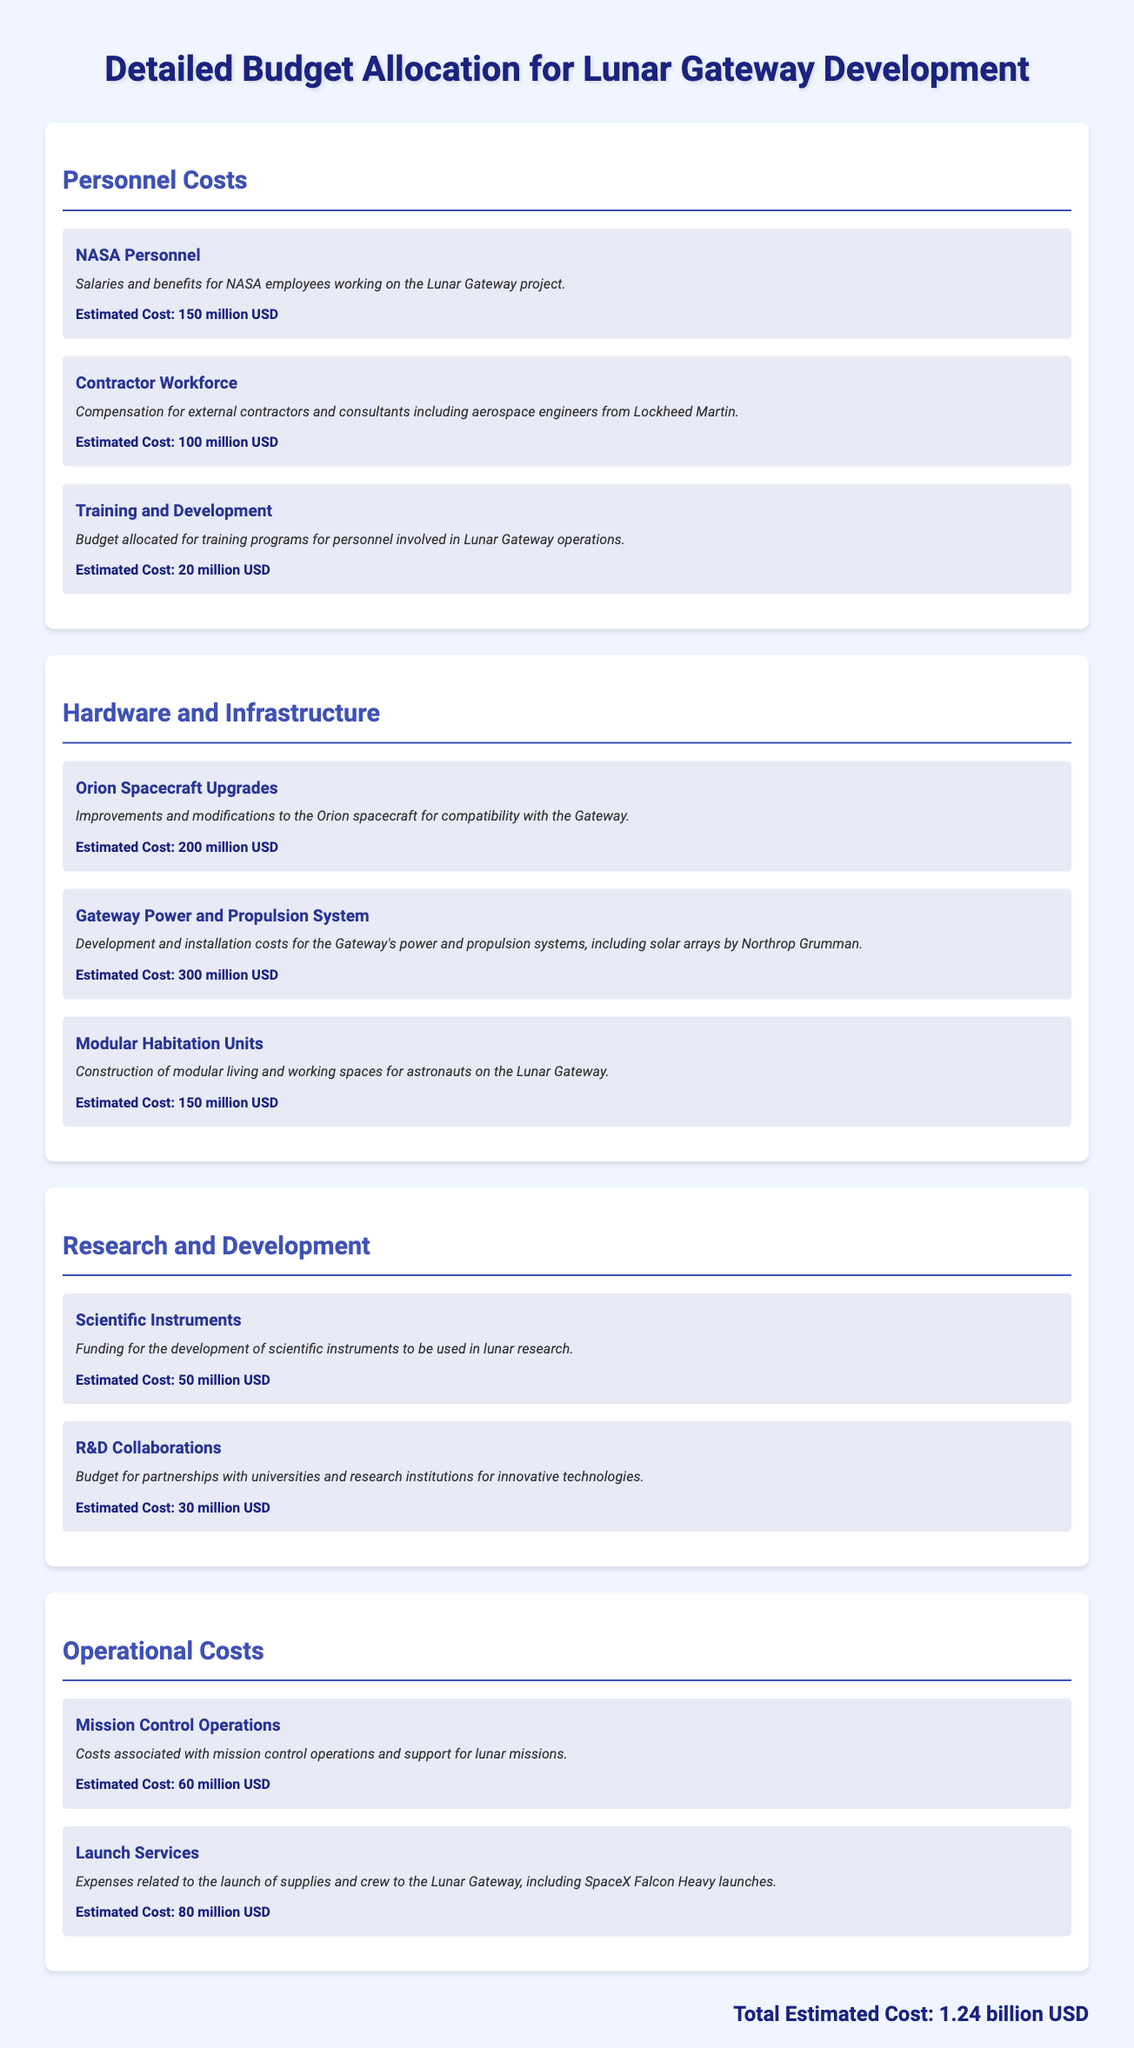What is the estimated cost for NASA Personnel? The estimated cost for NASA Personnel is explicitly mentioned in the document as 150 million USD.
Answer: 150 million USD What is the total estimated cost for the Lunar Gateway Development? The total estimated cost is summarized at the end of the document, which accounts for all budget allocations provided.
Answer: 1.24 billion USD What does the budget for Training and Development mainly cover? The document specifies that the budget for Training and Development is allocated for training programs for personnel involved in Lunar Gateway operations.
Answer: Training programs for personnel How much is allocated for the Gateway Power and Propulsion System? The document states the estimated cost for the Gateway Power and Propulsion System is clearly outlined as part of the hardware costs.
Answer: 300 million USD What is the estimated cost for R&D Collaborations? The cost for R&D Collaborations is mentioned in the Research and Development section of the document.
Answer: 30 million USD Which contractor is mentioned for the Contractor Workforce? The document mentions Lockheed Martin as the contractor contributing to the Contractor Workforce.
Answer: Lockheed Martin What are the expenses related to Launch Services estimated at? The estimated cost for Launch Services is detailed in the Operational Costs section of the document.
Answer: 80 million USD What is included in the Modular Habitation Units budget? The document describes the Modular Habitation Units budget as funding for the construction of modular living and working spaces for astronauts.
Answer: Construction of modular living and working spaces What major hardware upgrade is associated with the Orion spacecraft? The budget explanation indicates that upgrades focus on improvements and modifications to ensure compatibility with the Gateway.
Answer: Improvements and modifications to Orion spacecraft 